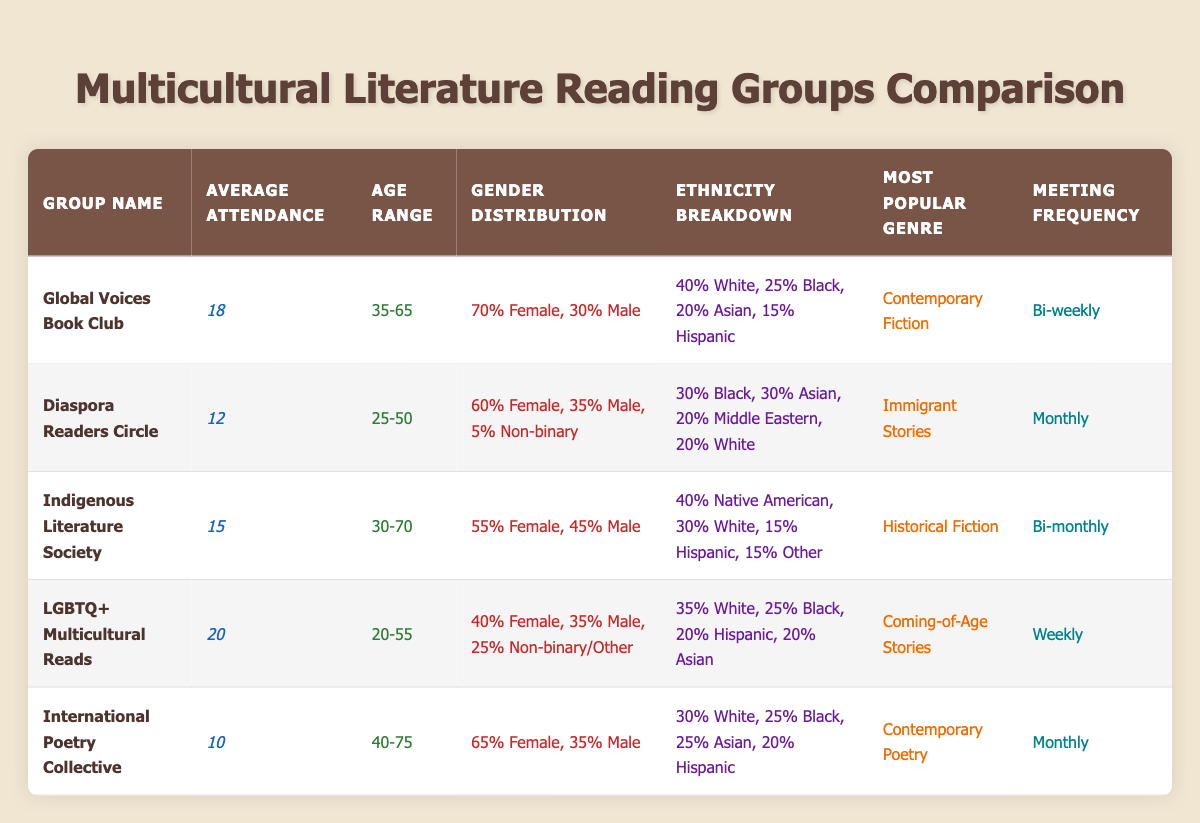What is the average attendance for the "Global Voices Book Club"? The table shows that the average attendance for the "Global Voices Book Club" is 18.
Answer: 18 Which reading group has the highest average attendance? By examining the average attendance column, the "LGBTQ+ Multicultural Reads" has the highest attendance at 20.
Answer: LGBTQ+ Multicultural Reads How many total attendees would be expected if all reading groups met at their average attendance? The total average attendance can be calculated by summing the averages: 18 + 12 + 15 + 20 + 10 = 85.
Answer: 85 Is the "Diaspora Readers Circle" more diverse in terms of ethnicity than the "Indigenous Literature Society"? The "Diaspora Readers Circle" includes multiple ethnic groups with a balanced breakdown of 30% each for Black and Asian, and 20% for Middle Eastern and White, while the "Indigenous Literature Society" has a larger portion of Native American at 40% and White at 30%. This suggests that the "Diaspora Readers Circle" has a more diverse ethnic composition overall.
Answer: Yes What percentage of attendees in the "Global Voices Book Club" are male? The gender distribution shows 30% male in the "Global Voices Book Club".
Answer: 30% Which reading group meets most frequently and what genre do they focus on? The "LGBTQ+ Multicultural Reads" meets weekly and its most popular genre is "Coming-of-Age Stories".
Answer: Weekly, Coming-of-Age Stories What is the average age range of attendees across all reading groups? The age ranges are 35-65, 25-50, 30-70, 20-55, and 40-75. To find the average, calculate the midpoints: (50 + 37.5 + 50 + 37.5 + 57.5) / 5 = 46.25. Thus, the average age range can be approximated around 46.25 years.
Answer: Approximately 46.25 How do the gender distributions compare between the "LGBTQ+ Multicultural Reads" and the "Indigenous Literature Society"? The "LGBTQ+ Multicultural Reads" has a gender distribution of 40% female, 35% male, and 25% non-binary/other, whereas the "Indigenous Literature Society" has 55% female, and 45% male. The roundness of the representation slightly leans more towards females in the latter group, with more diversity in the former due to the non-binary representation.
Answer: More balanced in LGBTQ+ Multicultural Reads Which reading group has the least average attendance and what is its most popular genre? The "International Poetry Collective" has the least average attendance at 10, and its most popular genre is "Contemporary Poetry".
Answer: International Poetry Collective, Contemporary Poetry 